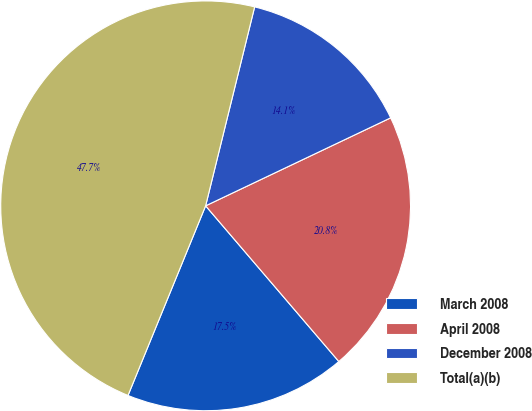Convert chart to OTSL. <chart><loc_0><loc_0><loc_500><loc_500><pie_chart><fcel>March 2008<fcel>April 2008<fcel>December 2008<fcel>Total(a)(b)<nl><fcel>17.45%<fcel>20.8%<fcel>14.09%<fcel>47.66%<nl></chart> 